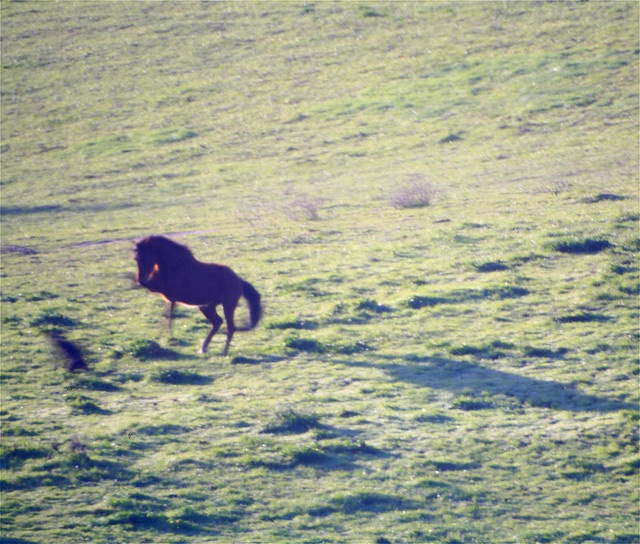Describe the objects in this image and their specific colors. I can see a horse in gray, navy, purple, and darkgray tones in this image. 